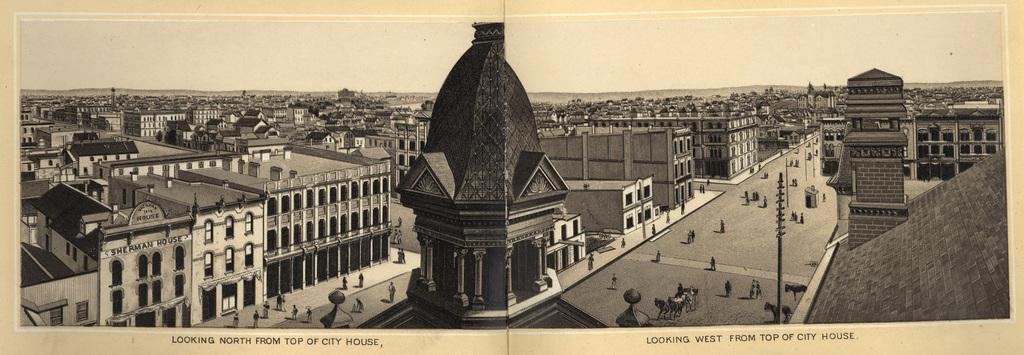What type of structures can be seen in the image? There are buildings in the image. What mode of transportation is present in the image? There is a horse cart in the image. What is happening on the road in the image? There is a crowd on the road in the image. What can be seen in the sky in the image? The sky is visible at the top of the image. What time of day does the image appear to be taken? The image appears to be taken during the day. How many quinces are being traded in the image? There is no mention of quinces or any trading activity in the image. What color is the spot on the horse cart in the image? There is no spot on the horse cart in the image. 